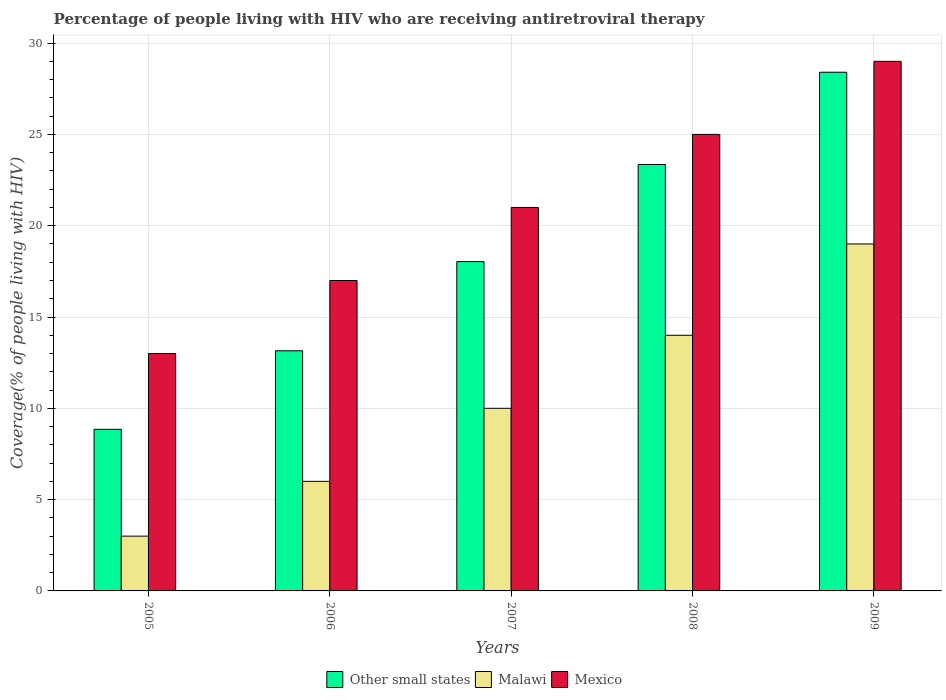Are the number of bars per tick equal to the number of legend labels?
Offer a terse response. Yes. Are the number of bars on each tick of the X-axis equal?
Make the answer very short. Yes. How many bars are there on the 1st tick from the left?
Your answer should be very brief. 3. In how many cases, is the number of bars for a given year not equal to the number of legend labels?
Make the answer very short. 0. What is the percentage of the HIV infected people who are receiving antiretroviral therapy in Other small states in 2009?
Your response must be concise. 28.4. Across all years, what is the maximum percentage of the HIV infected people who are receiving antiretroviral therapy in Malawi?
Give a very brief answer. 19. Across all years, what is the minimum percentage of the HIV infected people who are receiving antiretroviral therapy in Malawi?
Ensure brevity in your answer.  3. What is the total percentage of the HIV infected people who are receiving antiretroviral therapy in Other small states in the graph?
Your response must be concise. 91.79. What is the difference between the percentage of the HIV infected people who are receiving antiretroviral therapy in Other small states in 2005 and that in 2007?
Your answer should be compact. -9.18. What is the difference between the percentage of the HIV infected people who are receiving antiretroviral therapy in Malawi in 2009 and the percentage of the HIV infected people who are receiving antiretroviral therapy in Mexico in 2006?
Ensure brevity in your answer.  2. What is the average percentage of the HIV infected people who are receiving antiretroviral therapy in Malawi per year?
Keep it short and to the point. 10.4. In the year 2009, what is the difference between the percentage of the HIV infected people who are receiving antiretroviral therapy in Mexico and percentage of the HIV infected people who are receiving antiretroviral therapy in Malawi?
Keep it short and to the point. 10. In how many years, is the percentage of the HIV infected people who are receiving antiretroviral therapy in Other small states greater than 23 %?
Your answer should be very brief. 2. Is the percentage of the HIV infected people who are receiving antiretroviral therapy in Mexico in 2007 less than that in 2009?
Your response must be concise. Yes. Is the difference between the percentage of the HIV infected people who are receiving antiretroviral therapy in Mexico in 2005 and 2006 greater than the difference between the percentage of the HIV infected people who are receiving antiretroviral therapy in Malawi in 2005 and 2006?
Offer a very short reply. No. What is the difference between the highest and the second highest percentage of the HIV infected people who are receiving antiretroviral therapy in Other small states?
Keep it short and to the point. 5.05. What is the difference between the highest and the lowest percentage of the HIV infected people who are receiving antiretroviral therapy in Mexico?
Your answer should be very brief. 16. Is the sum of the percentage of the HIV infected people who are receiving antiretroviral therapy in Mexico in 2008 and 2009 greater than the maximum percentage of the HIV infected people who are receiving antiretroviral therapy in Other small states across all years?
Provide a short and direct response. Yes. What does the 3rd bar from the left in 2009 represents?
Your response must be concise. Mexico. How many years are there in the graph?
Provide a succinct answer. 5. What is the difference between two consecutive major ticks on the Y-axis?
Offer a terse response. 5. How many legend labels are there?
Your answer should be very brief. 3. How are the legend labels stacked?
Provide a short and direct response. Horizontal. What is the title of the graph?
Your response must be concise. Percentage of people living with HIV who are receiving antiretroviral therapy. What is the label or title of the X-axis?
Your answer should be very brief. Years. What is the label or title of the Y-axis?
Offer a terse response. Coverage(% of people living with HIV). What is the Coverage(% of people living with HIV) in Other small states in 2005?
Your answer should be compact. 8.85. What is the Coverage(% of people living with HIV) in Other small states in 2006?
Ensure brevity in your answer.  13.15. What is the Coverage(% of people living with HIV) in Malawi in 2006?
Your answer should be compact. 6. What is the Coverage(% of people living with HIV) of Other small states in 2007?
Your answer should be compact. 18.04. What is the Coverage(% of people living with HIV) in Malawi in 2007?
Offer a very short reply. 10. What is the Coverage(% of people living with HIV) in Other small states in 2008?
Your answer should be very brief. 23.35. What is the Coverage(% of people living with HIV) in Mexico in 2008?
Offer a terse response. 25. What is the Coverage(% of people living with HIV) in Other small states in 2009?
Your answer should be compact. 28.4. What is the Coverage(% of people living with HIV) in Malawi in 2009?
Give a very brief answer. 19. Across all years, what is the maximum Coverage(% of people living with HIV) in Other small states?
Offer a terse response. 28.4. Across all years, what is the maximum Coverage(% of people living with HIV) in Malawi?
Offer a terse response. 19. Across all years, what is the minimum Coverage(% of people living with HIV) in Other small states?
Your response must be concise. 8.85. What is the total Coverage(% of people living with HIV) in Other small states in the graph?
Provide a short and direct response. 91.79. What is the total Coverage(% of people living with HIV) in Malawi in the graph?
Give a very brief answer. 52. What is the total Coverage(% of people living with HIV) of Mexico in the graph?
Your answer should be compact. 105. What is the difference between the Coverage(% of people living with HIV) in Other small states in 2005 and that in 2006?
Provide a succinct answer. -4.3. What is the difference between the Coverage(% of people living with HIV) of Other small states in 2005 and that in 2007?
Provide a succinct answer. -9.18. What is the difference between the Coverage(% of people living with HIV) in Mexico in 2005 and that in 2007?
Offer a very short reply. -8. What is the difference between the Coverage(% of people living with HIV) of Other small states in 2005 and that in 2008?
Provide a succinct answer. -14.5. What is the difference between the Coverage(% of people living with HIV) of Mexico in 2005 and that in 2008?
Your answer should be very brief. -12. What is the difference between the Coverage(% of people living with HIV) of Other small states in 2005 and that in 2009?
Give a very brief answer. -19.55. What is the difference between the Coverage(% of people living with HIV) of Mexico in 2005 and that in 2009?
Make the answer very short. -16. What is the difference between the Coverage(% of people living with HIV) of Other small states in 2006 and that in 2007?
Provide a succinct answer. -4.88. What is the difference between the Coverage(% of people living with HIV) in Malawi in 2006 and that in 2007?
Make the answer very short. -4. What is the difference between the Coverage(% of people living with HIV) of Other small states in 2006 and that in 2008?
Give a very brief answer. -10.2. What is the difference between the Coverage(% of people living with HIV) of Mexico in 2006 and that in 2008?
Make the answer very short. -8. What is the difference between the Coverage(% of people living with HIV) in Other small states in 2006 and that in 2009?
Provide a short and direct response. -15.25. What is the difference between the Coverage(% of people living with HIV) of Malawi in 2006 and that in 2009?
Your response must be concise. -13. What is the difference between the Coverage(% of people living with HIV) in Mexico in 2006 and that in 2009?
Offer a terse response. -12. What is the difference between the Coverage(% of people living with HIV) of Other small states in 2007 and that in 2008?
Ensure brevity in your answer.  -5.32. What is the difference between the Coverage(% of people living with HIV) of Malawi in 2007 and that in 2008?
Ensure brevity in your answer.  -4. What is the difference between the Coverage(% of people living with HIV) in Mexico in 2007 and that in 2008?
Offer a very short reply. -4. What is the difference between the Coverage(% of people living with HIV) of Other small states in 2007 and that in 2009?
Make the answer very short. -10.37. What is the difference between the Coverage(% of people living with HIV) of Malawi in 2007 and that in 2009?
Your answer should be very brief. -9. What is the difference between the Coverage(% of people living with HIV) of Mexico in 2007 and that in 2009?
Provide a succinct answer. -8. What is the difference between the Coverage(% of people living with HIV) of Other small states in 2008 and that in 2009?
Provide a short and direct response. -5.05. What is the difference between the Coverage(% of people living with HIV) in Malawi in 2008 and that in 2009?
Ensure brevity in your answer.  -5. What is the difference between the Coverage(% of people living with HIV) of Mexico in 2008 and that in 2009?
Your response must be concise. -4. What is the difference between the Coverage(% of people living with HIV) of Other small states in 2005 and the Coverage(% of people living with HIV) of Malawi in 2006?
Keep it short and to the point. 2.85. What is the difference between the Coverage(% of people living with HIV) in Other small states in 2005 and the Coverage(% of people living with HIV) in Mexico in 2006?
Provide a short and direct response. -8.15. What is the difference between the Coverage(% of people living with HIV) of Malawi in 2005 and the Coverage(% of people living with HIV) of Mexico in 2006?
Keep it short and to the point. -14. What is the difference between the Coverage(% of people living with HIV) in Other small states in 2005 and the Coverage(% of people living with HIV) in Malawi in 2007?
Your answer should be very brief. -1.15. What is the difference between the Coverage(% of people living with HIV) in Other small states in 2005 and the Coverage(% of people living with HIV) in Mexico in 2007?
Provide a succinct answer. -12.15. What is the difference between the Coverage(% of people living with HIV) in Malawi in 2005 and the Coverage(% of people living with HIV) in Mexico in 2007?
Provide a short and direct response. -18. What is the difference between the Coverage(% of people living with HIV) of Other small states in 2005 and the Coverage(% of people living with HIV) of Malawi in 2008?
Provide a succinct answer. -5.15. What is the difference between the Coverage(% of people living with HIV) in Other small states in 2005 and the Coverage(% of people living with HIV) in Mexico in 2008?
Your answer should be compact. -16.15. What is the difference between the Coverage(% of people living with HIV) in Other small states in 2005 and the Coverage(% of people living with HIV) in Malawi in 2009?
Ensure brevity in your answer.  -10.15. What is the difference between the Coverage(% of people living with HIV) in Other small states in 2005 and the Coverage(% of people living with HIV) in Mexico in 2009?
Make the answer very short. -20.15. What is the difference between the Coverage(% of people living with HIV) of Other small states in 2006 and the Coverage(% of people living with HIV) of Malawi in 2007?
Your response must be concise. 3.15. What is the difference between the Coverage(% of people living with HIV) of Other small states in 2006 and the Coverage(% of people living with HIV) of Mexico in 2007?
Offer a very short reply. -7.85. What is the difference between the Coverage(% of people living with HIV) in Malawi in 2006 and the Coverage(% of people living with HIV) in Mexico in 2007?
Your response must be concise. -15. What is the difference between the Coverage(% of people living with HIV) in Other small states in 2006 and the Coverage(% of people living with HIV) in Malawi in 2008?
Ensure brevity in your answer.  -0.85. What is the difference between the Coverage(% of people living with HIV) of Other small states in 2006 and the Coverage(% of people living with HIV) of Mexico in 2008?
Your answer should be compact. -11.85. What is the difference between the Coverage(% of people living with HIV) in Other small states in 2006 and the Coverage(% of people living with HIV) in Malawi in 2009?
Ensure brevity in your answer.  -5.85. What is the difference between the Coverage(% of people living with HIV) in Other small states in 2006 and the Coverage(% of people living with HIV) in Mexico in 2009?
Your answer should be very brief. -15.85. What is the difference between the Coverage(% of people living with HIV) of Other small states in 2007 and the Coverage(% of people living with HIV) of Malawi in 2008?
Ensure brevity in your answer.  4.04. What is the difference between the Coverage(% of people living with HIV) in Other small states in 2007 and the Coverage(% of people living with HIV) in Mexico in 2008?
Provide a succinct answer. -6.96. What is the difference between the Coverage(% of people living with HIV) in Malawi in 2007 and the Coverage(% of people living with HIV) in Mexico in 2008?
Offer a very short reply. -15. What is the difference between the Coverage(% of people living with HIV) of Other small states in 2007 and the Coverage(% of people living with HIV) of Malawi in 2009?
Your answer should be very brief. -0.96. What is the difference between the Coverage(% of people living with HIV) of Other small states in 2007 and the Coverage(% of people living with HIV) of Mexico in 2009?
Keep it short and to the point. -10.96. What is the difference between the Coverage(% of people living with HIV) of Malawi in 2007 and the Coverage(% of people living with HIV) of Mexico in 2009?
Your response must be concise. -19. What is the difference between the Coverage(% of people living with HIV) of Other small states in 2008 and the Coverage(% of people living with HIV) of Malawi in 2009?
Make the answer very short. 4.35. What is the difference between the Coverage(% of people living with HIV) of Other small states in 2008 and the Coverage(% of people living with HIV) of Mexico in 2009?
Give a very brief answer. -5.65. What is the average Coverage(% of people living with HIV) of Other small states per year?
Your response must be concise. 18.36. What is the average Coverage(% of people living with HIV) of Malawi per year?
Ensure brevity in your answer.  10.4. In the year 2005, what is the difference between the Coverage(% of people living with HIV) of Other small states and Coverage(% of people living with HIV) of Malawi?
Offer a very short reply. 5.85. In the year 2005, what is the difference between the Coverage(% of people living with HIV) in Other small states and Coverage(% of people living with HIV) in Mexico?
Your answer should be very brief. -4.15. In the year 2006, what is the difference between the Coverage(% of people living with HIV) in Other small states and Coverage(% of people living with HIV) in Malawi?
Offer a very short reply. 7.15. In the year 2006, what is the difference between the Coverage(% of people living with HIV) of Other small states and Coverage(% of people living with HIV) of Mexico?
Give a very brief answer. -3.85. In the year 2006, what is the difference between the Coverage(% of people living with HIV) in Malawi and Coverage(% of people living with HIV) in Mexico?
Your answer should be compact. -11. In the year 2007, what is the difference between the Coverage(% of people living with HIV) in Other small states and Coverage(% of people living with HIV) in Malawi?
Keep it short and to the point. 8.04. In the year 2007, what is the difference between the Coverage(% of people living with HIV) in Other small states and Coverage(% of people living with HIV) in Mexico?
Keep it short and to the point. -2.96. In the year 2007, what is the difference between the Coverage(% of people living with HIV) of Malawi and Coverage(% of people living with HIV) of Mexico?
Your answer should be very brief. -11. In the year 2008, what is the difference between the Coverage(% of people living with HIV) of Other small states and Coverage(% of people living with HIV) of Malawi?
Provide a succinct answer. 9.35. In the year 2008, what is the difference between the Coverage(% of people living with HIV) of Other small states and Coverage(% of people living with HIV) of Mexico?
Offer a terse response. -1.65. In the year 2008, what is the difference between the Coverage(% of people living with HIV) in Malawi and Coverage(% of people living with HIV) in Mexico?
Offer a very short reply. -11. In the year 2009, what is the difference between the Coverage(% of people living with HIV) in Other small states and Coverage(% of people living with HIV) in Malawi?
Make the answer very short. 9.4. In the year 2009, what is the difference between the Coverage(% of people living with HIV) of Other small states and Coverage(% of people living with HIV) of Mexico?
Your response must be concise. -0.6. In the year 2009, what is the difference between the Coverage(% of people living with HIV) in Malawi and Coverage(% of people living with HIV) in Mexico?
Your response must be concise. -10. What is the ratio of the Coverage(% of people living with HIV) in Other small states in 2005 to that in 2006?
Give a very brief answer. 0.67. What is the ratio of the Coverage(% of people living with HIV) in Mexico in 2005 to that in 2006?
Provide a succinct answer. 0.76. What is the ratio of the Coverage(% of people living with HIV) in Other small states in 2005 to that in 2007?
Provide a short and direct response. 0.49. What is the ratio of the Coverage(% of people living with HIV) in Mexico in 2005 to that in 2007?
Make the answer very short. 0.62. What is the ratio of the Coverage(% of people living with HIV) in Other small states in 2005 to that in 2008?
Provide a short and direct response. 0.38. What is the ratio of the Coverage(% of people living with HIV) of Malawi in 2005 to that in 2008?
Provide a succinct answer. 0.21. What is the ratio of the Coverage(% of people living with HIV) in Mexico in 2005 to that in 2008?
Ensure brevity in your answer.  0.52. What is the ratio of the Coverage(% of people living with HIV) in Other small states in 2005 to that in 2009?
Your answer should be compact. 0.31. What is the ratio of the Coverage(% of people living with HIV) of Malawi in 2005 to that in 2009?
Your answer should be very brief. 0.16. What is the ratio of the Coverage(% of people living with HIV) in Mexico in 2005 to that in 2009?
Provide a short and direct response. 0.45. What is the ratio of the Coverage(% of people living with HIV) in Other small states in 2006 to that in 2007?
Provide a short and direct response. 0.73. What is the ratio of the Coverage(% of people living with HIV) of Malawi in 2006 to that in 2007?
Provide a short and direct response. 0.6. What is the ratio of the Coverage(% of people living with HIV) in Mexico in 2006 to that in 2007?
Your answer should be very brief. 0.81. What is the ratio of the Coverage(% of people living with HIV) of Other small states in 2006 to that in 2008?
Make the answer very short. 0.56. What is the ratio of the Coverage(% of people living with HIV) in Malawi in 2006 to that in 2008?
Your answer should be compact. 0.43. What is the ratio of the Coverage(% of people living with HIV) in Mexico in 2006 to that in 2008?
Ensure brevity in your answer.  0.68. What is the ratio of the Coverage(% of people living with HIV) of Other small states in 2006 to that in 2009?
Your answer should be compact. 0.46. What is the ratio of the Coverage(% of people living with HIV) in Malawi in 2006 to that in 2009?
Give a very brief answer. 0.32. What is the ratio of the Coverage(% of people living with HIV) in Mexico in 2006 to that in 2009?
Your response must be concise. 0.59. What is the ratio of the Coverage(% of people living with HIV) in Other small states in 2007 to that in 2008?
Offer a terse response. 0.77. What is the ratio of the Coverage(% of people living with HIV) in Malawi in 2007 to that in 2008?
Provide a short and direct response. 0.71. What is the ratio of the Coverage(% of people living with HIV) in Mexico in 2007 to that in 2008?
Make the answer very short. 0.84. What is the ratio of the Coverage(% of people living with HIV) of Other small states in 2007 to that in 2009?
Your response must be concise. 0.63. What is the ratio of the Coverage(% of people living with HIV) in Malawi in 2007 to that in 2009?
Provide a succinct answer. 0.53. What is the ratio of the Coverage(% of people living with HIV) in Mexico in 2007 to that in 2009?
Offer a very short reply. 0.72. What is the ratio of the Coverage(% of people living with HIV) of Other small states in 2008 to that in 2009?
Make the answer very short. 0.82. What is the ratio of the Coverage(% of people living with HIV) of Malawi in 2008 to that in 2009?
Offer a very short reply. 0.74. What is the ratio of the Coverage(% of people living with HIV) in Mexico in 2008 to that in 2009?
Your response must be concise. 0.86. What is the difference between the highest and the second highest Coverage(% of people living with HIV) in Other small states?
Give a very brief answer. 5.05. What is the difference between the highest and the lowest Coverage(% of people living with HIV) in Other small states?
Give a very brief answer. 19.55. What is the difference between the highest and the lowest Coverage(% of people living with HIV) of Mexico?
Ensure brevity in your answer.  16. 